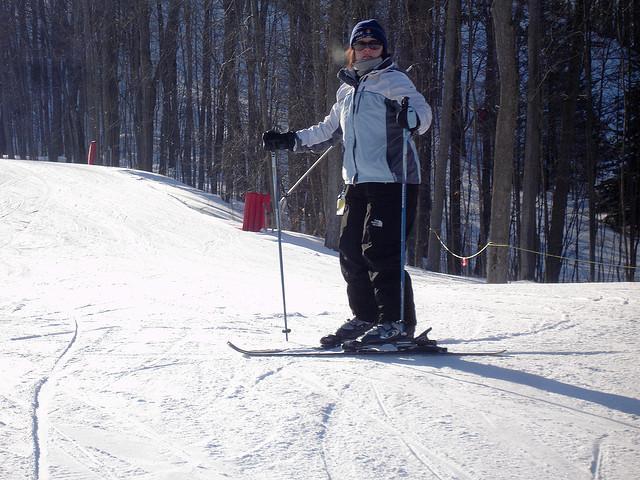How many ski poles does the person have?
Give a very brief answer. 2. 